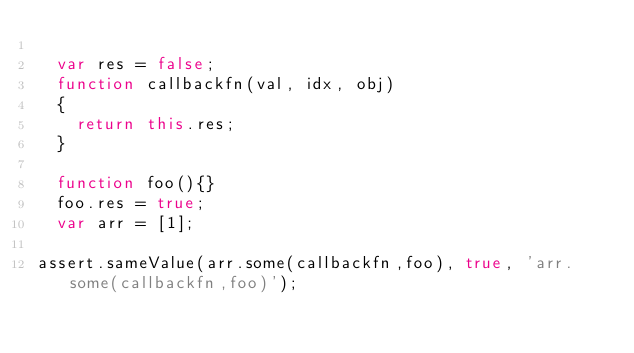Convert code to text. <code><loc_0><loc_0><loc_500><loc_500><_JavaScript_>
  var res = false;
  function callbackfn(val, idx, obj)
  {
    return this.res;
  }

  function foo(){}
  foo.res = true;
  var arr = [1];

assert.sameValue(arr.some(callbackfn,foo), true, 'arr.some(callbackfn,foo)');
</code> 